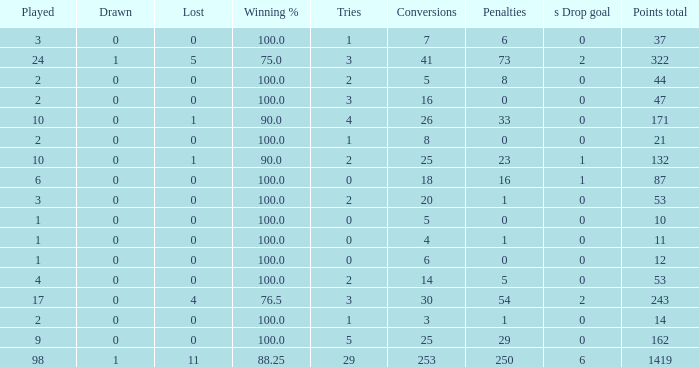How many ties did he have when he had 1 penalties and more than 20 conversions? None. 